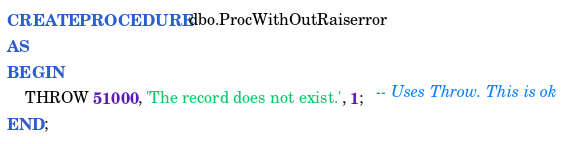<code> <loc_0><loc_0><loc_500><loc_500><_SQL_>CREATE PROCEDURE dbo.ProcWithOutRaiserror
AS 
BEGIN
    THROW 51000, 'The record does not exist.', 1;   -- Uses Throw. This is ok
END;</code> 